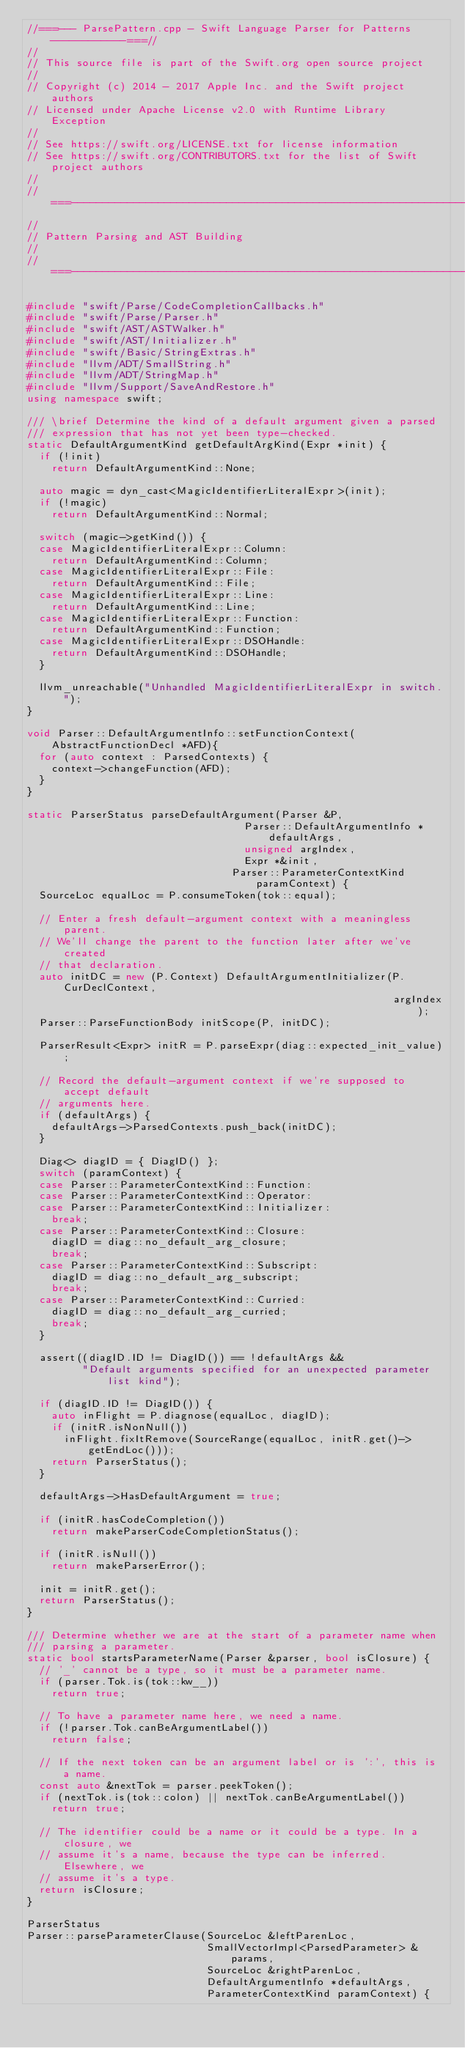Convert code to text. <code><loc_0><loc_0><loc_500><loc_500><_C++_>//===--- ParsePattern.cpp - Swift Language Parser for Patterns ------------===//
//
// This source file is part of the Swift.org open source project
//
// Copyright (c) 2014 - 2017 Apple Inc. and the Swift project authors
// Licensed under Apache License v2.0 with Runtime Library Exception
//
// See https://swift.org/LICENSE.txt for license information
// See https://swift.org/CONTRIBUTORS.txt for the list of Swift project authors
//
//===----------------------------------------------------------------------===//
//
// Pattern Parsing and AST Building
//
//===----------------------------------------------------------------------===//

#include "swift/Parse/CodeCompletionCallbacks.h"
#include "swift/Parse/Parser.h"
#include "swift/AST/ASTWalker.h"
#include "swift/AST/Initializer.h"
#include "swift/Basic/StringExtras.h"
#include "llvm/ADT/SmallString.h"
#include "llvm/ADT/StringMap.h"
#include "llvm/Support/SaveAndRestore.h"
using namespace swift;

/// \brief Determine the kind of a default argument given a parsed
/// expression that has not yet been type-checked.
static DefaultArgumentKind getDefaultArgKind(Expr *init) {
  if (!init)
    return DefaultArgumentKind::None;

  auto magic = dyn_cast<MagicIdentifierLiteralExpr>(init);
  if (!magic)
    return DefaultArgumentKind::Normal;

  switch (magic->getKind()) {
  case MagicIdentifierLiteralExpr::Column:
    return DefaultArgumentKind::Column;
  case MagicIdentifierLiteralExpr::File:
    return DefaultArgumentKind::File;
  case MagicIdentifierLiteralExpr::Line:
    return DefaultArgumentKind::Line;
  case MagicIdentifierLiteralExpr::Function:
    return DefaultArgumentKind::Function;
  case MagicIdentifierLiteralExpr::DSOHandle:
    return DefaultArgumentKind::DSOHandle;
  }

  llvm_unreachable("Unhandled MagicIdentifierLiteralExpr in switch.");
}

void Parser::DefaultArgumentInfo::setFunctionContext(AbstractFunctionDecl *AFD){
  for (auto context : ParsedContexts) {
    context->changeFunction(AFD);
  }
}

static ParserStatus parseDefaultArgument(Parser &P,
                                   Parser::DefaultArgumentInfo *defaultArgs,
                                   unsigned argIndex,
                                   Expr *&init,
                                 Parser::ParameterContextKind paramContext) {
  SourceLoc equalLoc = P.consumeToken(tok::equal);

  // Enter a fresh default-argument context with a meaningless parent.
  // We'll change the parent to the function later after we've created
  // that declaration.
  auto initDC = new (P.Context) DefaultArgumentInitializer(P.CurDeclContext,
                                                           argIndex);
  Parser::ParseFunctionBody initScope(P, initDC);

  ParserResult<Expr> initR = P.parseExpr(diag::expected_init_value);

  // Record the default-argument context if we're supposed to accept default
  // arguments here.
  if (defaultArgs) {
    defaultArgs->ParsedContexts.push_back(initDC);
  }

  Diag<> diagID = { DiagID() };
  switch (paramContext) {
  case Parser::ParameterContextKind::Function:
  case Parser::ParameterContextKind::Operator:
  case Parser::ParameterContextKind::Initializer:
    break;
  case Parser::ParameterContextKind::Closure:
    diagID = diag::no_default_arg_closure;
    break;
  case Parser::ParameterContextKind::Subscript:
    diagID = diag::no_default_arg_subscript;
    break;
  case Parser::ParameterContextKind::Curried:
    diagID = diag::no_default_arg_curried;
    break;
  }
  
  assert((diagID.ID != DiagID()) == !defaultArgs &&
         "Default arguments specified for an unexpected parameter list kind");
  
  if (diagID.ID != DiagID()) {
    auto inFlight = P.diagnose(equalLoc, diagID);
    if (initR.isNonNull())
      inFlight.fixItRemove(SourceRange(equalLoc, initR.get()->getEndLoc()));
    return ParserStatus();
  }
  
  defaultArgs->HasDefaultArgument = true;

  if (initR.hasCodeCompletion())
    return makeParserCodeCompletionStatus();

  if (initR.isNull())
    return makeParserError();

  init = initR.get();
  return ParserStatus();
}

/// Determine whether we are at the start of a parameter name when
/// parsing a parameter.
static bool startsParameterName(Parser &parser, bool isClosure) {
  // '_' cannot be a type, so it must be a parameter name.
  if (parser.Tok.is(tok::kw__))
    return true;

  // To have a parameter name here, we need a name.
  if (!parser.Tok.canBeArgumentLabel())
    return false;

  // If the next token can be an argument label or is ':', this is a name.
  const auto &nextTok = parser.peekToken();
  if (nextTok.is(tok::colon) || nextTok.canBeArgumentLabel())
    return true;

  // The identifier could be a name or it could be a type. In a closure, we
  // assume it's a name, because the type can be inferred. Elsewhere, we
  // assume it's a type.
  return isClosure;
}

ParserStatus
Parser::parseParameterClause(SourceLoc &leftParenLoc,
                             SmallVectorImpl<ParsedParameter> &params,
                             SourceLoc &rightParenLoc,
                             DefaultArgumentInfo *defaultArgs,
                             ParameterContextKind paramContext) {</code> 